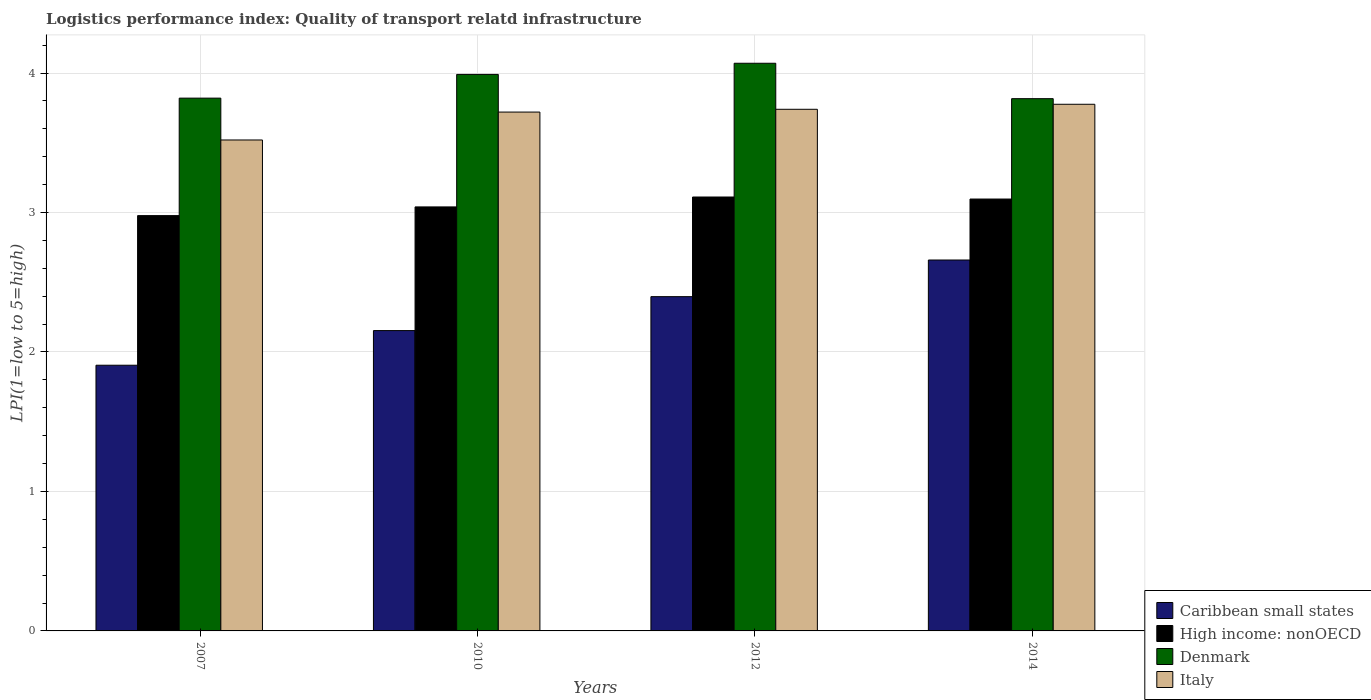How many different coloured bars are there?
Your response must be concise. 4. Are the number of bars per tick equal to the number of legend labels?
Give a very brief answer. Yes. Are the number of bars on each tick of the X-axis equal?
Offer a terse response. Yes. How many bars are there on the 3rd tick from the right?
Your answer should be compact. 4. What is the label of the 4th group of bars from the left?
Offer a very short reply. 2014. In how many cases, is the number of bars for a given year not equal to the number of legend labels?
Offer a terse response. 0. What is the logistics performance index in High income: nonOECD in 2007?
Provide a short and direct response. 2.98. Across all years, what is the maximum logistics performance index in Italy?
Your answer should be compact. 3.78. Across all years, what is the minimum logistics performance index in Caribbean small states?
Make the answer very short. 1.91. In which year was the logistics performance index in Italy maximum?
Provide a succinct answer. 2014. In which year was the logistics performance index in Italy minimum?
Ensure brevity in your answer.  2007. What is the total logistics performance index in Caribbean small states in the graph?
Your answer should be very brief. 9.11. What is the difference between the logistics performance index in Caribbean small states in 2010 and that in 2014?
Your response must be concise. -0.51. What is the difference between the logistics performance index in Denmark in 2007 and the logistics performance index in Italy in 2010?
Give a very brief answer. 0.1. What is the average logistics performance index in Caribbean small states per year?
Keep it short and to the point. 2.28. In the year 2007, what is the difference between the logistics performance index in High income: nonOECD and logistics performance index in Caribbean small states?
Your response must be concise. 1.07. What is the ratio of the logistics performance index in Caribbean small states in 2012 to that in 2014?
Keep it short and to the point. 0.9. Is the logistics performance index in Caribbean small states in 2012 less than that in 2014?
Your response must be concise. Yes. What is the difference between the highest and the second highest logistics performance index in Denmark?
Make the answer very short. 0.08. What is the difference between the highest and the lowest logistics performance index in Denmark?
Offer a very short reply. 0.25. In how many years, is the logistics performance index in Denmark greater than the average logistics performance index in Denmark taken over all years?
Your answer should be very brief. 2. Is the sum of the logistics performance index in Denmark in 2010 and 2014 greater than the maximum logistics performance index in Italy across all years?
Offer a very short reply. Yes. Is it the case that in every year, the sum of the logistics performance index in Caribbean small states and logistics performance index in Italy is greater than the sum of logistics performance index in High income: nonOECD and logistics performance index in Denmark?
Give a very brief answer. Yes. What does the 1st bar from the left in 2007 represents?
Ensure brevity in your answer.  Caribbean small states. What does the 4th bar from the right in 2007 represents?
Offer a very short reply. Caribbean small states. How many bars are there?
Make the answer very short. 16. Are all the bars in the graph horizontal?
Your response must be concise. No. How many years are there in the graph?
Your response must be concise. 4. Are the values on the major ticks of Y-axis written in scientific E-notation?
Offer a very short reply. No. Does the graph contain any zero values?
Provide a succinct answer. No. Does the graph contain grids?
Offer a very short reply. Yes. Where does the legend appear in the graph?
Give a very brief answer. Bottom right. How many legend labels are there?
Ensure brevity in your answer.  4. What is the title of the graph?
Your answer should be very brief. Logistics performance index: Quality of transport relatd infrastructure. Does "Switzerland" appear as one of the legend labels in the graph?
Your answer should be compact. No. What is the label or title of the X-axis?
Offer a very short reply. Years. What is the label or title of the Y-axis?
Your response must be concise. LPI(1=low to 5=high). What is the LPI(1=low to 5=high) in Caribbean small states in 2007?
Give a very brief answer. 1.91. What is the LPI(1=low to 5=high) of High income: nonOECD in 2007?
Make the answer very short. 2.98. What is the LPI(1=low to 5=high) of Denmark in 2007?
Offer a very short reply. 3.82. What is the LPI(1=low to 5=high) in Italy in 2007?
Ensure brevity in your answer.  3.52. What is the LPI(1=low to 5=high) of Caribbean small states in 2010?
Your response must be concise. 2.15. What is the LPI(1=low to 5=high) in High income: nonOECD in 2010?
Give a very brief answer. 3.04. What is the LPI(1=low to 5=high) of Denmark in 2010?
Your response must be concise. 3.99. What is the LPI(1=low to 5=high) of Italy in 2010?
Keep it short and to the point. 3.72. What is the LPI(1=low to 5=high) of Caribbean small states in 2012?
Your response must be concise. 2.4. What is the LPI(1=low to 5=high) of High income: nonOECD in 2012?
Offer a terse response. 3.11. What is the LPI(1=low to 5=high) of Denmark in 2012?
Provide a succinct answer. 4.07. What is the LPI(1=low to 5=high) in Italy in 2012?
Ensure brevity in your answer.  3.74. What is the LPI(1=low to 5=high) of Caribbean small states in 2014?
Your answer should be very brief. 2.66. What is the LPI(1=low to 5=high) of High income: nonOECD in 2014?
Provide a short and direct response. 3.1. What is the LPI(1=low to 5=high) in Denmark in 2014?
Your answer should be compact. 3.82. What is the LPI(1=low to 5=high) of Italy in 2014?
Your answer should be very brief. 3.78. Across all years, what is the maximum LPI(1=low to 5=high) in Caribbean small states?
Your answer should be very brief. 2.66. Across all years, what is the maximum LPI(1=low to 5=high) in High income: nonOECD?
Provide a short and direct response. 3.11. Across all years, what is the maximum LPI(1=low to 5=high) of Denmark?
Keep it short and to the point. 4.07. Across all years, what is the maximum LPI(1=low to 5=high) in Italy?
Offer a very short reply. 3.78. Across all years, what is the minimum LPI(1=low to 5=high) of Caribbean small states?
Give a very brief answer. 1.91. Across all years, what is the minimum LPI(1=low to 5=high) of High income: nonOECD?
Give a very brief answer. 2.98. Across all years, what is the minimum LPI(1=low to 5=high) in Denmark?
Provide a short and direct response. 3.82. Across all years, what is the minimum LPI(1=low to 5=high) of Italy?
Your answer should be compact. 3.52. What is the total LPI(1=low to 5=high) in Caribbean small states in the graph?
Keep it short and to the point. 9.11. What is the total LPI(1=low to 5=high) in High income: nonOECD in the graph?
Your answer should be very brief. 12.23. What is the total LPI(1=low to 5=high) in Denmark in the graph?
Keep it short and to the point. 15.7. What is the total LPI(1=low to 5=high) of Italy in the graph?
Keep it short and to the point. 14.76. What is the difference between the LPI(1=low to 5=high) in Caribbean small states in 2007 and that in 2010?
Ensure brevity in your answer.  -0.25. What is the difference between the LPI(1=low to 5=high) in High income: nonOECD in 2007 and that in 2010?
Keep it short and to the point. -0.06. What is the difference between the LPI(1=low to 5=high) in Denmark in 2007 and that in 2010?
Give a very brief answer. -0.17. What is the difference between the LPI(1=low to 5=high) in Italy in 2007 and that in 2010?
Ensure brevity in your answer.  -0.2. What is the difference between the LPI(1=low to 5=high) of Caribbean small states in 2007 and that in 2012?
Offer a terse response. -0.49. What is the difference between the LPI(1=low to 5=high) of High income: nonOECD in 2007 and that in 2012?
Your answer should be very brief. -0.13. What is the difference between the LPI(1=low to 5=high) of Italy in 2007 and that in 2012?
Provide a short and direct response. -0.22. What is the difference between the LPI(1=low to 5=high) in Caribbean small states in 2007 and that in 2014?
Make the answer very short. -0.75. What is the difference between the LPI(1=low to 5=high) in High income: nonOECD in 2007 and that in 2014?
Provide a succinct answer. -0.12. What is the difference between the LPI(1=low to 5=high) in Denmark in 2007 and that in 2014?
Provide a short and direct response. 0. What is the difference between the LPI(1=low to 5=high) in Italy in 2007 and that in 2014?
Ensure brevity in your answer.  -0.26. What is the difference between the LPI(1=low to 5=high) in Caribbean small states in 2010 and that in 2012?
Your response must be concise. -0.24. What is the difference between the LPI(1=low to 5=high) of High income: nonOECD in 2010 and that in 2012?
Provide a short and direct response. -0.07. What is the difference between the LPI(1=low to 5=high) in Denmark in 2010 and that in 2012?
Your answer should be very brief. -0.08. What is the difference between the LPI(1=low to 5=high) of Italy in 2010 and that in 2012?
Provide a succinct answer. -0.02. What is the difference between the LPI(1=low to 5=high) of Caribbean small states in 2010 and that in 2014?
Your answer should be compact. -0.51. What is the difference between the LPI(1=low to 5=high) in High income: nonOECD in 2010 and that in 2014?
Ensure brevity in your answer.  -0.06. What is the difference between the LPI(1=low to 5=high) of Denmark in 2010 and that in 2014?
Provide a short and direct response. 0.17. What is the difference between the LPI(1=low to 5=high) of Italy in 2010 and that in 2014?
Provide a short and direct response. -0.06. What is the difference between the LPI(1=low to 5=high) in Caribbean small states in 2012 and that in 2014?
Give a very brief answer. -0.26. What is the difference between the LPI(1=low to 5=high) of High income: nonOECD in 2012 and that in 2014?
Give a very brief answer. 0.01. What is the difference between the LPI(1=low to 5=high) in Denmark in 2012 and that in 2014?
Keep it short and to the point. 0.25. What is the difference between the LPI(1=low to 5=high) in Italy in 2012 and that in 2014?
Your response must be concise. -0.04. What is the difference between the LPI(1=low to 5=high) in Caribbean small states in 2007 and the LPI(1=low to 5=high) in High income: nonOECD in 2010?
Your response must be concise. -1.14. What is the difference between the LPI(1=low to 5=high) of Caribbean small states in 2007 and the LPI(1=low to 5=high) of Denmark in 2010?
Keep it short and to the point. -2.08. What is the difference between the LPI(1=low to 5=high) in Caribbean small states in 2007 and the LPI(1=low to 5=high) in Italy in 2010?
Offer a terse response. -1.81. What is the difference between the LPI(1=low to 5=high) of High income: nonOECD in 2007 and the LPI(1=low to 5=high) of Denmark in 2010?
Your answer should be compact. -1.01. What is the difference between the LPI(1=low to 5=high) in High income: nonOECD in 2007 and the LPI(1=low to 5=high) in Italy in 2010?
Give a very brief answer. -0.74. What is the difference between the LPI(1=low to 5=high) of Caribbean small states in 2007 and the LPI(1=low to 5=high) of High income: nonOECD in 2012?
Provide a succinct answer. -1.21. What is the difference between the LPI(1=low to 5=high) in Caribbean small states in 2007 and the LPI(1=low to 5=high) in Denmark in 2012?
Give a very brief answer. -2.17. What is the difference between the LPI(1=low to 5=high) in Caribbean small states in 2007 and the LPI(1=low to 5=high) in Italy in 2012?
Ensure brevity in your answer.  -1.83. What is the difference between the LPI(1=low to 5=high) in High income: nonOECD in 2007 and the LPI(1=low to 5=high) in Denmark in 2012?
Give a very brief answer. -1.09. What is the difference between the LPI(1=low to 5=high) of High income: nonOECD in 2007 and the LPI(1=low to 5=high) of Italy in 2012?
Make the answer very short. -0.76. What is the difference between the LPI(1=low to 5=high) in Denmark in 2007 and the LPI(1=low to 5=high) in Italy in 2012?
Give a very brief answer. 0.08. What is the difference between the LPI(1=low to 5=high) in Caribbean small states in 2007 and the LPI(1=low to 5=high) in High income: nonOECD in 2014?
Give a very brief answer. -1.19. What is the difference between the LPI(1=low to 5=high) of Caribbean small states in 2007 and the LPI(1=low to 5=high) of Denmark in 2014?
Keep it short and to the point. -1.91. What is the difference between the LPI(1=low to 5=high) in Caribbean small states in 2007 and the LPI(1=low to 5=high) in Italy in 2014?
Provide a short and direct response. -1.87. What is the difference between the LPI(1=low to 5=high) in High income: nonOECD in 2007 and the LPI(1=low to 5=high) in Denmark in 2014?
Provide a succinct answer. -0.84. What is the difference between the LPI(1=low to 5=high) in High income: nonOECD in 2007 and the LPI(1=low to 5=high) in Italy in 2014?
Provide a short and direct response. -0.8. What is the difference between the LPI(1=low to 5=high) of Denmark in 2007 and the LPI(1=low to 5=high) of Italy in 2014?
Provide a succinct answer. 0.04. What is the difference between the LPI(1=low to 5=high) of Caribbean small states in 2010 and the LPI(1=low to 5=high) of High income: nonOECD in 2012?
Provide a succinct answer. -0.96. What is the difference between the LPI(1=low to 5=high) of Caribbean small states in 2010 and the LPI(1=low to 5=high) of Denmark in 2012?
Offer a terse response. -1.92. What is the difference between the LPI(1=low to 5=high) of Caribbean small states in 2010 and the LPI(1=low to 5=high) of Italy in 2012?
Offer a very short reply. -1.59. What is the difference between the LPI(1=low to 5=high) in High income: nonOECD in 2010 and the LPI(1=low to 5=high) in Denmark in 2012?
Provide a succinct answer. -1.03. What is the difference between the LPI(1=low to 5=high) in High income: nonOECD in 2010 and the LPI(1=low to 5=high) in Italy in 2012?
Provide a short and direct response. -0.7. What is the difference between the LPI(1=low to 5=high) in Caribbean small states in 2010 and the LPI(1=low to 5=high) in High income: nonOECD in 2014?
Give a very brief answer. -0.94. What is the difference between the LPI(1=low to 5=high) in Caribbean small states in 2010 and the LPI(1=low to 5=high) in Denmark in 2014?
Offer a very short reply. -1.66. What is the difference between the LPI(1=low to 5=high) in Caribbean small states in 2010 and the LPI(1=low to 5=high) in Italy in 2014?
Offer a very short reply. -1.62. What is the difference between the LPI(1=low to 5=high) in High income: nonOECD in 2010 and the LPI(1=low to 5=high) in Denmark in 2014?
Provide a succinct answer. -0.78. What is the difference between the LPI(1=low to 5=high) in High income: nonOECD in 2010 and the LPI(1=low to 5=high) in Italy in 2014?
Provide a short and direct response. -0.74. What is the difference between the LPI(1=low to 5=high) of Denmark in 2010 and the LPI(1=low to 5=high) of Italy in 2014?
Your response must be concise. 0.21. What is the difference between the LPI(1=low to 5=high) in Caribbean small states in 2012 and the LPI(1=low to 5=high) in High income: nonOECD in 2014?
Give a very brief answer. -0.7. What is the difference between the LPI(1=low to 5=high) in Caribbean small states in 2012 and the LPI(1=low to 5=high) in Denmark in 2014?
Provide a succinct answer. -1.42. What is the difference between the LPI(1=low to 5=high) in Caribbean small states in 2012 and the LPI(1=low to 5=high) in Italy in 2014?
Your answer should be compact. -1.38. What is the difference between the LPI(1=low to 5=high) in High income: nonOECD in 2012 and the LPI(1=low to 5=high) in Denmark in 2014?
Provide a succinct answer. -0.71. What is the difference between the LPI(1=low to 5=high) of High income: nonOECD in 2012 and the LPI(1=low to 5=high) of Italy in 2014?
Offer a very short reply. -0.66. What is the difference between the LPI(1=low to 5=high) in Denmark in 2012 and the LPI(1=low to 5=high) in Italy in 2014?
Keep it short and to the point. 0.29. What is the average LPI(1=low to 5=high) of Caribbean small states per year?
Offer a very short reply. 2.28. What is the average LPI(1=low to 5=high) in High income: nonOECD per year?
Ensure brevity in your answer.  3.06. What is the average LPI(1=low to 5=high) in Denmark per year?
Offer a very short reply. 3.92. What is the average LPI(1=low to 5=high) of Italy per year?
Provide a short and direct response. 3.69. In the year 2007, what is the difference between the LPI(1=low to 5=high) in Caribbean small states and LPI(1=low to 5=high) in High income: nonOECD?
Your response must be concise. -1.07. In the year 2007, what is the difference between the LPI(1=low to 5=high) in Caribbean small states and LPI(1=low to 5=high) in Denmark?
Your response must be concise. -1.92. In the year 2007, what is the difference between the LPI(1=low to 5=high) of Caribbean small states and LPI(1=low to 5=high) of Italy?
Your answer should be very brief. -1.61. In the year 2007, what is the difference between the LPI(1=low to 5=high) in High income: nonOECD and LPI(1=low to 5=high) in Denmark?
Your answer should be compact. -0.84. In the year 2007, what is the difference between the LPI(1=low to 5=high) of High income: nonOECD and LPI(1=low to 5=high) of Italy?
Offer a terse response. -0.54. In the year 2010, what is the difference between the LPI(1=low to 5=high) in Caribbean small states and LPI(1=low to 5=high) in High income: nonOECD?
Provide a succinct answer. -0.89. In the year 2010, what is the difference between the LPI(1=low to 5=high) of Caribbean small states and LPI(1=low to 5=high) of Denmark?
Keep it short and to the point. -1.84. In the year 2010, what is the difference between the LPI(1=low to 5=high) in Caribbean small states and LPI(1=low to 5=high) in Italy?
Make the answer very short. -1.57. In the year 2010, what is the difference between the LPI(1=low to 5=high) in High income: nonOECD and LPI(1=low to 5=high) in Denmark?
Provide a short and direct response. -0.95. In the year 2010, what is the difference between the LPI(1=low to 5=high) of High income: nonOECD and LPI(1=low to 5=high) of Italy?
Ensure brevity in your answer.  -0.68. In the year 2010, what is the difference between the LPI(1=low to 5=high) of Denmark and LPI(1=low to 5=high) of Italy?
Give a very brief answer. 0.27. In the year 2012, what is the difference between the LPI(1=low to 5=high) in Caribbean small states and LPI(1=low to 5=high) in High income: nonOECD?
Provide a succinct answer. -0.71. In the year 2012, what is the difference between the LPI(1=low to 5=high) in Caribbean small states and LPI(1=low to 5=high) in Denmark?
Make the answer very short. -1.67. In the year 2012, what is the difference between the LPI(1=low to 5=high) in Caribbean small states and LPI(1=low to 5=high) in Italy?
Ensure brevity in your answer.  -1.34. In the year 2012, what is the difference between the LPI(1=low to 5=high) of High income: nonOECD and LPI(1=low to 5=high) of Denmark?
Your answer should be very brief. -0.96. In the year 2012, what is the difference between the LPI(1=low to 5=high) in High income: nonOECD and LPI(1=low to 5=high) in Italy?
Offer a terse response. -0.63. In the year 2012, what is the difference between the LPI(1=low to 5=high) of Denmark and LPI(1=low to 5=high) of Italy?
Your answer should be very brief. 0.33. In the year 2014, what is the difference between the LPI(1=low to 5=high) in Caribbean small states and LPI(1=low to 5=high) in High income: nonOECD?
Offer a very short reply. -0.44. In the year 2014, what is the difference between the LPI(1=low to 5=high) in Caribbean small states and LPI(1=low to 5=high) in Denmark?
Keep it short and to the point. -1.16. In the year 2014, what is the difference between the LPI(1=low to 5=high) of Caribbean small states and LPI(1=low to 5=high) of Italy?
Ensure brevity in your answer.  -1.12. In the year 2014, what is the difference between the LPI(1=low to 5=high) in High income: nonOECD and LPI(1=low to 5=high) in Denmark?
Give a very brief answer. -0.72. In the year 2014, what is the difference between the LPI(1=low to 5=high) of High income: nonOECD and LPI(1=low to 5=high) of Italy?
Offer a terse response. -0.68. In the year 2014, what is the difference between the LPI(1=low to 5=high) of Denmark and LPI(1=low to 5=high) of Italy?
Keep it short and to the point. 0.04. What is the ratio of the LPI(1=low to 5=high) in Caribbean small states in 2007 to that in 2010?
Keep it short and to the point. 0.88. What is the ratio of the LPI(1=low to 5=high) of High income: nonOECD in 2007 to that in 2010?
Provide a succinct answer. 0.98. What is the ratio of the LPI(1=low to 5=high) of Denmark in 2007 to that in 2010?
Provide a short and direct response. 0.96. What is the ratio of the LPI(1=low to 5=high) of Italy in 2007 to that in 2010?
Keep it short and to the point. 0.95. What is the ratio of the LPI(1=low to 5=high) in Caribbean small states in 2007 to that in 2012?
Make the answer very short. 0.79. What is the ratio of the LPI(1=low to 5=high) in High income: nonOECD in 2007 to that in 2012?
Provide a succinct answer. 0.96. What is the ratio of the LPI(1=low to 5=high) of Denmark in 2007 to that in 2012?
Keep it short and to the point. 0.94. What is the ratio of the LPI(1=low to 5=high) of Caribbean small states in 2007 to that in 2014?
Your answer should be compact. 0.72. What is the ratio of the LPI(1=low to 5=high) of High income: nonOECD in 2007 to that in 2014?
Ensure brevity in your answer.  0.96. What is the ratio of the LPI(1=low to 5=high) in Denmark in 2007 to that in 2014?
Offer a very short reply. 1. What is the ratio of the LPI(1=low to 5=high) in Italy in 2007 to that in 2014?
Make the answer very short. 0.93. What is the ratio of the LPI(1=low to 5=high) of Caribbean small states in 2010 to that in 2012?
Offer a terse response. 0.9. What is the ratio of the LPI(1=low to 5=high) of High income: nonOECD in 2010 to that in 2012?
Ensure brevity in your answer.  0.98. What is the ratio of the LPI(1=low to 5=high) of Denmark in 2010 to that in 2012?
Provide a succinct answer. 0.98. What is the ratio of the LPI(1=low to 5=high) of Caribbean small states in 2010 to that in 2014?
Offer a very short reply. 0.81. What is the ratio of the LPI(1=low to 5=high) of High income: nonOECD in 2010 to that in 2014?
Offer a very short reply. 0.98. What is the ratio of the LPI(1=low to 5=high) of Denmark in 2010 to that in 2014?
Keep it short and to the point. 1.05. What is the ratio of the LPI(1=low to 5=high) in Italy in 2010 to that in 2014?
Your response must be concise. 0.99. What is the ratio of the LPI(1=low to 5=high) of Caribbean small states in 2012 to that in 2014?
Provide a short and direct response. 0.9. What is the ratio of the LPI(1=low to 5=high) in Denmark in 2012 to that in 2014?
Provide a succinct answer. 1.07. What is the difference between the highest and the second highest LPI(1=low to 5=high) of Caribbean small states?
Your answer should be very brief. 0.26. What is the difference between the highest and the second highest LPI(1=low to 5=high) of High income: nonOECD?
Provide a succinct answer. 0.01. What is the difference between the highest and the second highest LPI(1=low to 5=high) in Italy?
Provide a short and direct response. 0.04. What is the difference between the highest and the lowest LPI(1=low to 5=high) of Caribbean small states?
Ensure brevity in your answer.  0.75. What is the difference between the highest and the lowest LPI(1=low to 5=high) in High income: nonOECD?
Ensure brevity in your answer.  0.13. What is the difference between the highest and the lowest LPI(1=low to 5=high) of Denmark?
Keep it short and to the point. 0.25. What is the difference between the highest and the lowest LPI(1=low to 5=high) of Italy?
Offer a very short reply. 0.26. 